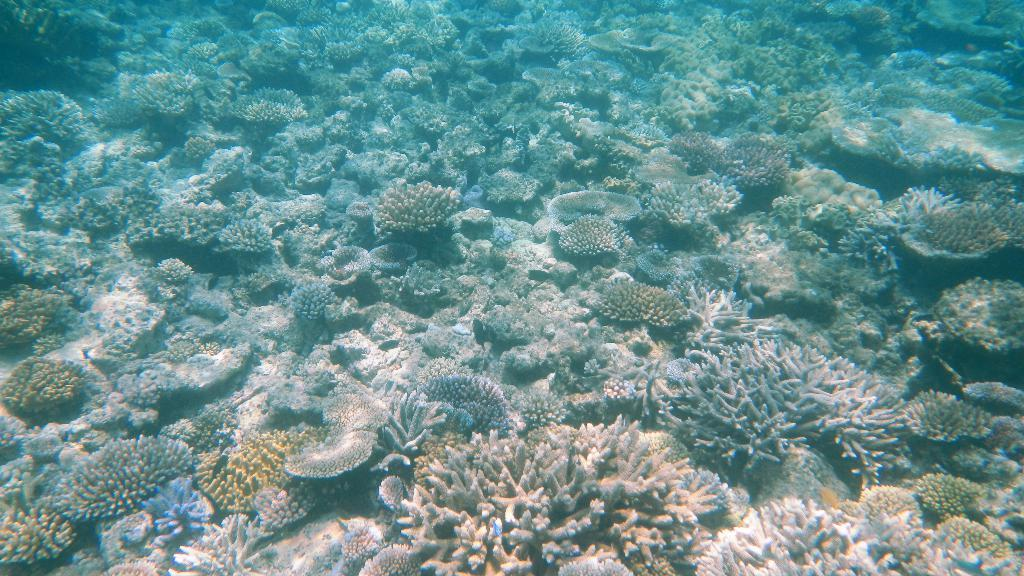What type of environment is shown in the image? The image depicts an underground water environment. How many passengers are visible in the image? There are no passengers present in the image, as it depicts an underground water environment. What type of basin is visible in the image? There is no basin present in the image; it depicts an underground water environment. 